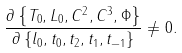<formula> <loc_0><loc_0><loc_500><loc_500>\frac { \partial \left \{ T _ { 0 } , L _ { 0 } , C ^ { 2 } , C ^ { 3 } , \Phi \right \} } { \partial \left \{ l _ { 0 } , t _ { 0 } , t _ { 2 } , t _ { 1 } , t _ { - 1 } \right \} } \neq 0 .</formula> 